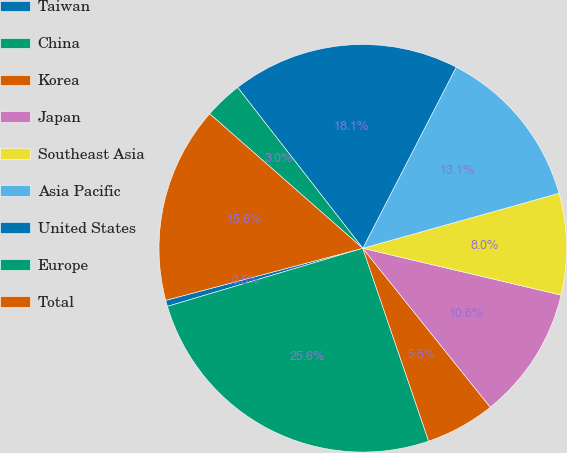<chart> <loc_0><loc_0><loc_500><loc_500><pie_chart><fcel>Taiwan<fcel>China<fcel>Korea<fcel>Japan<fcel>Southeast Asia<fcel>Asia Pacific<fcel>United States<fcel>Europe<fcel>Total<nl><fcel>0.49%<fcel>25.64%<fcel>5.52%<fcel>10.55%<fcel>8.04%<fcel>13.07%<fcel>18.1%<fcel>3.01%<fcel>15.58%<nl></chart> 